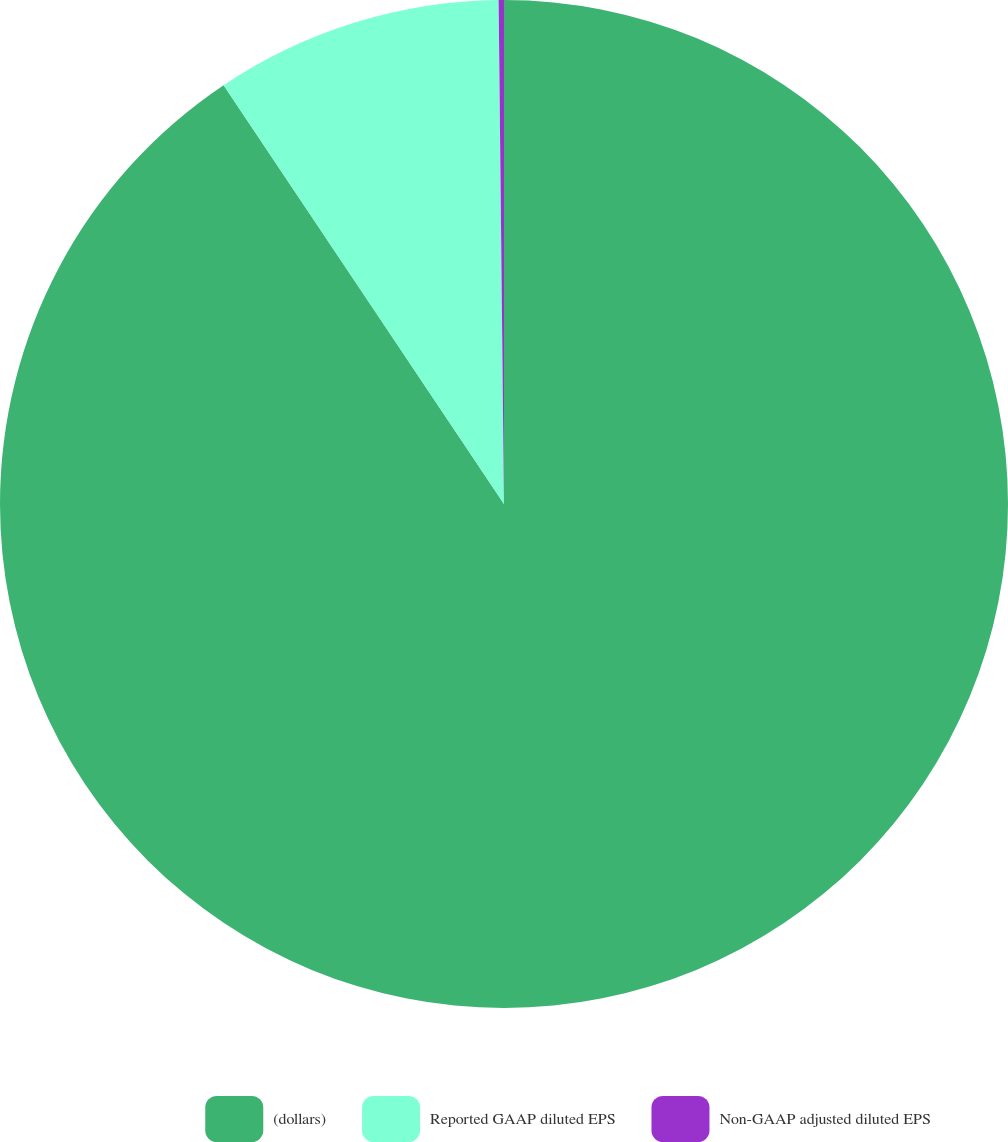Convert chart. <chart><loc_0><loc_0><loc_500><loc_500><pie_chart><fcel>(dollars)<fcel>Reported GAAP diluted EPS<fcel>Non-GAAP adjusted diluted EPS<nl><fcel>90.61%<fcel>9.22%<fcel>0.17%<nl></chart> 